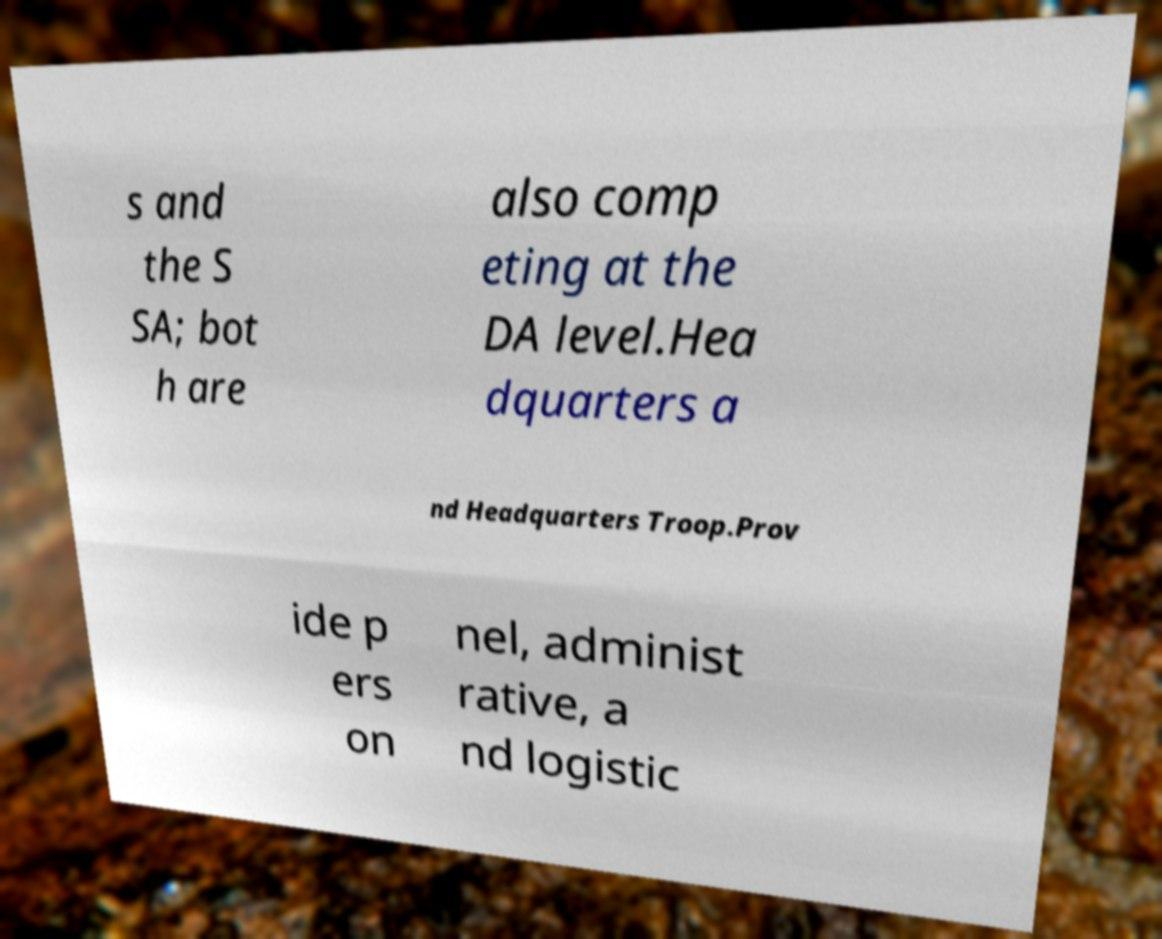Can you read and provide the text displayed in the image?This photo seems to have some interesting text. Can you extract and type it out for me? s and the S SA; bot h are also comp eting at the DA level.Hea dquarters a nd Headquarters Troop.Prov ide p ers on nel, administ rative, a nd logistic 